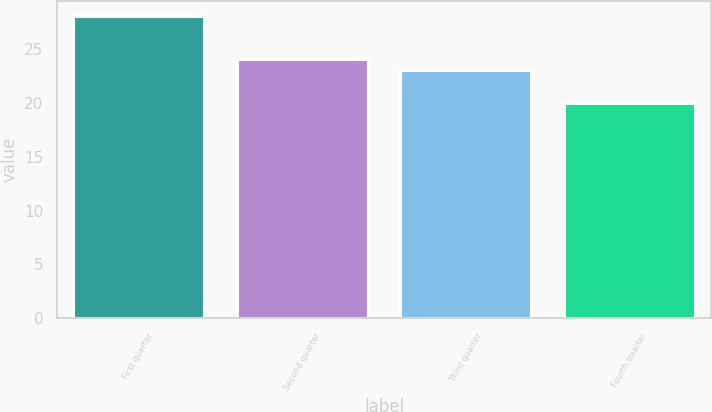Convert chart. <chart><loc_0><loc_0><loc_500><loc_500><bar_chart><fcel>First quarter<fcel>Second quarter<fcel>Third quarter<fcel>Fourth quarter<nl><fcel>28<fcel>24<fcel>23<fcel>20<nl></chart> 